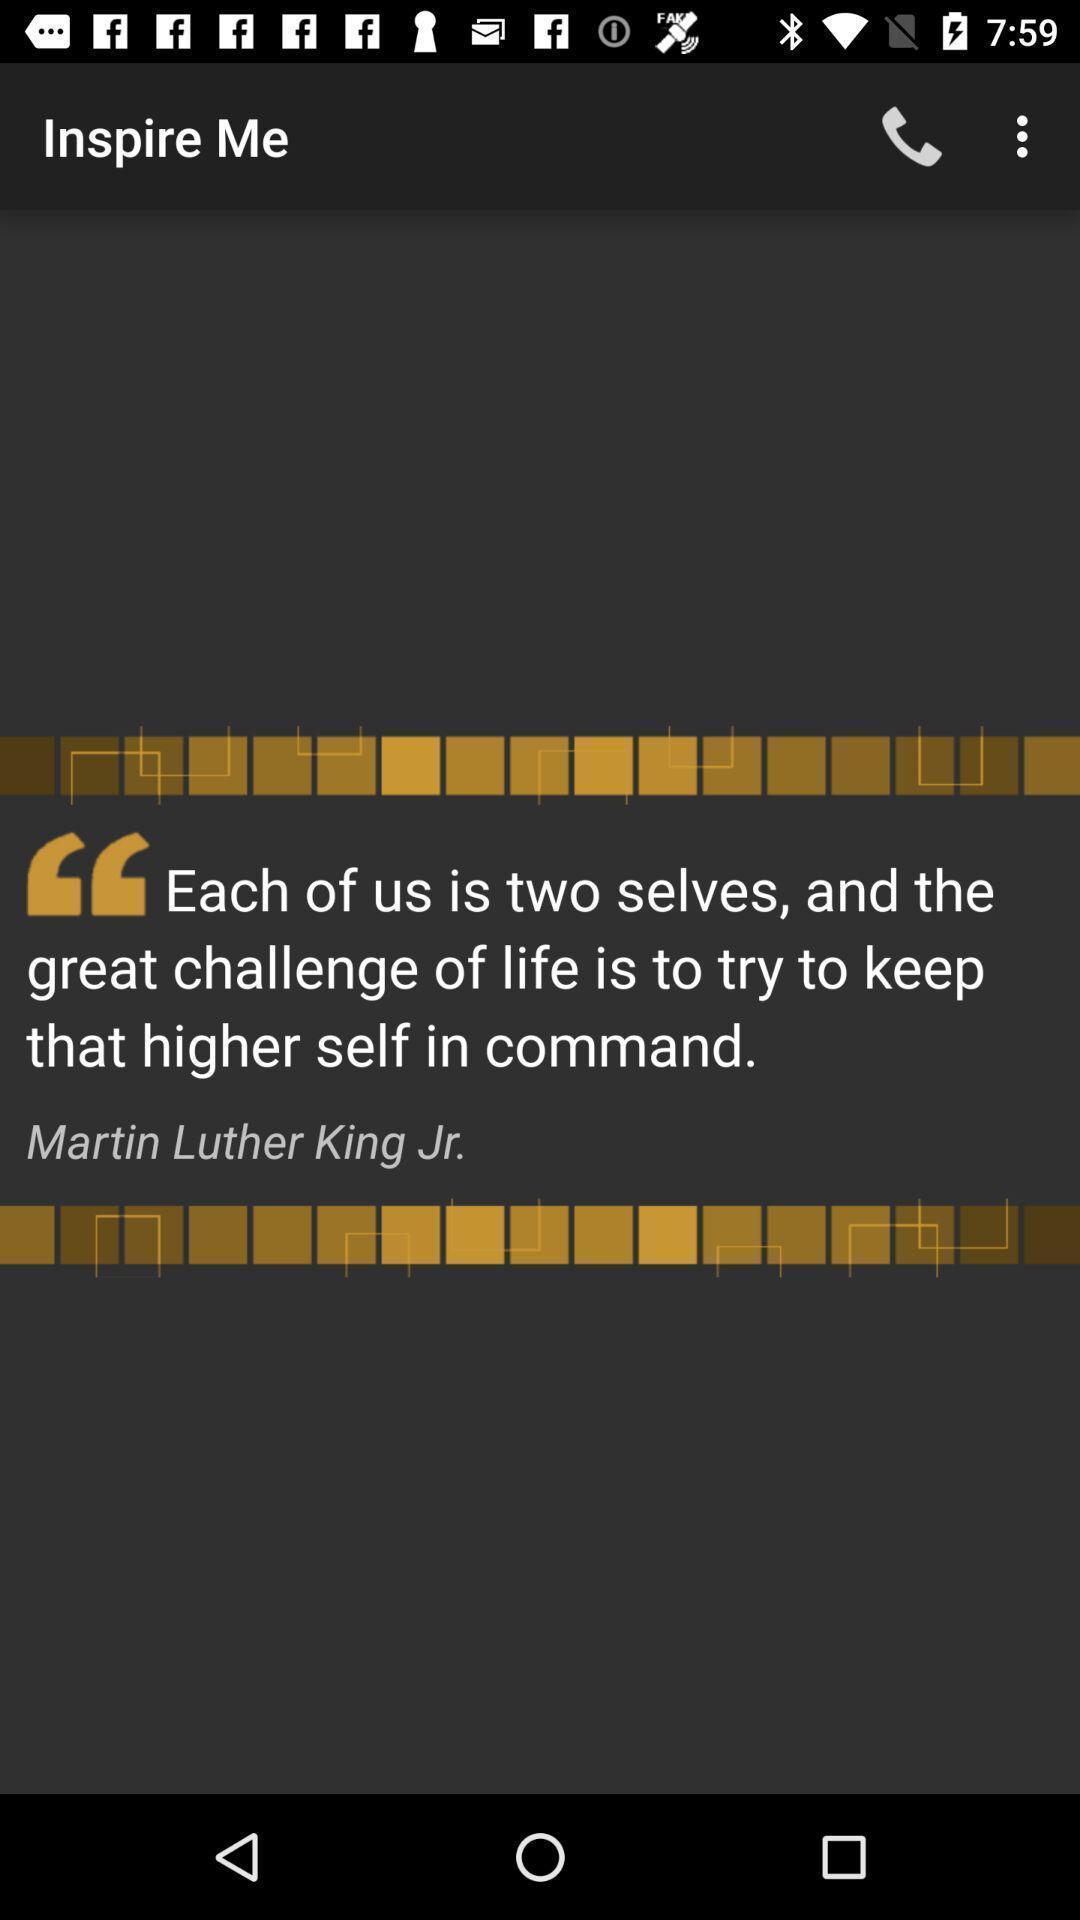Describe this image in words. Screen displaying about inspirational quote. 